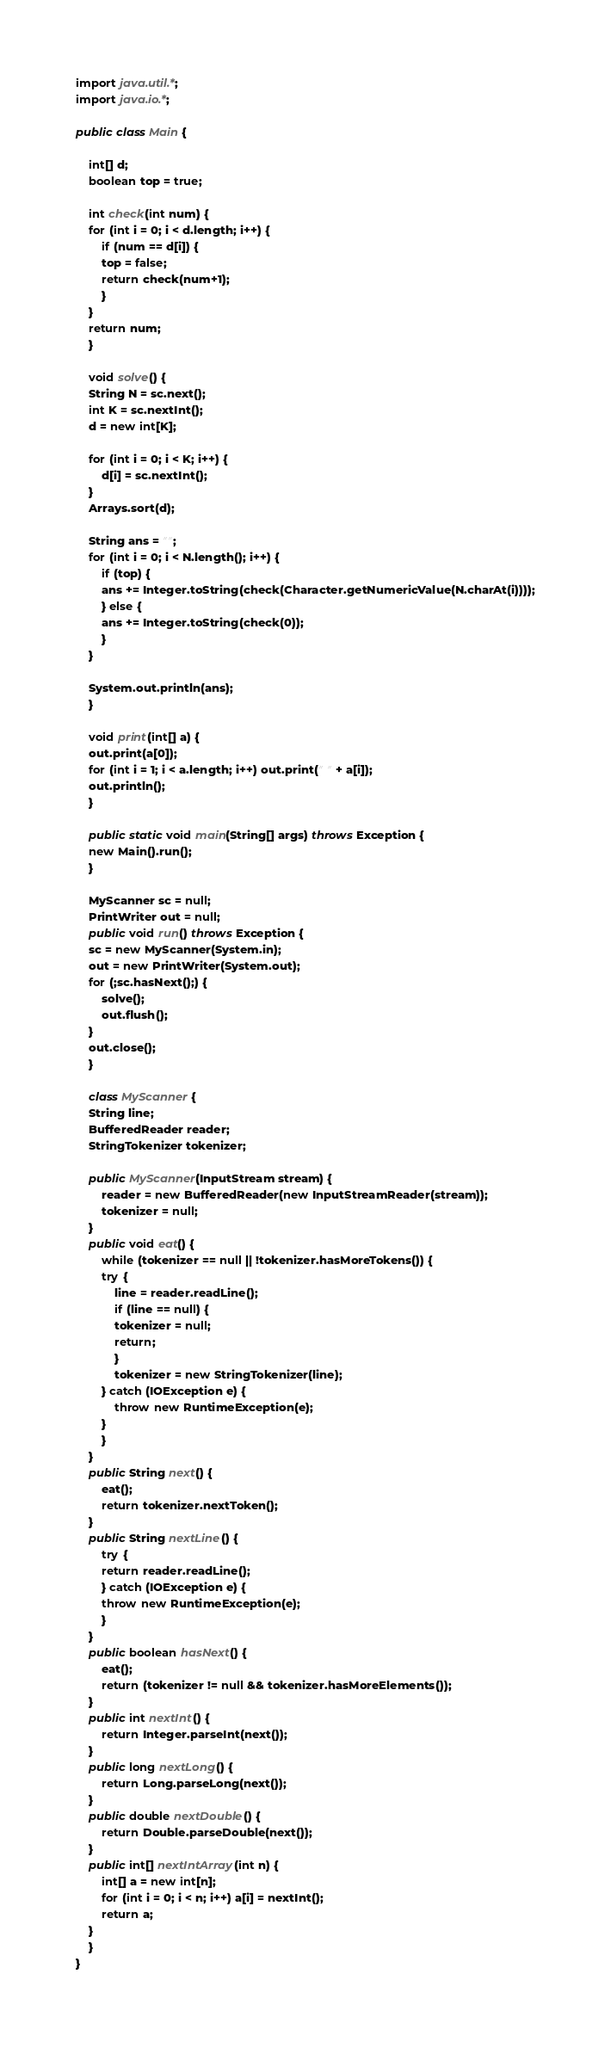Convert code to text. <code><loc_0><loc_0><loc_500><loc_500><_Java_>import java.util.*;
import java.io.*;

public class Main {

    int[] d;
    boolean top = true;

    int check(int num) {
	for (int i = 0; i < d.length; i++) {
	    if (num == d[i]) {
		top = false;
		return check(num+1);
	    }
	}
	return num;
    }

    void solve() {
	String N = sc.next();
	int K = sc.nextInt();
	d = new int[K];

	for (int i = 0; i < K; i++) {
	    d[i] = sc.nextInt();
	}
	Arrays.sort(d);

	String ans = "";
	for (int i = 0; i < N.length(); i++) {
	    if (top) {
		ans += Integer.toString(check(Character.getNumericValue(N.charAt(i))));
	    } else {
		ans += Integer.toString(check(0));
	    }
	}

	System.out.println(ans);
    }

    void print(int[] a) {
	out.print(a[0]);
	for (int i = 1; i < a.length; i++) out.print(" " + a[i]);
	out.println();
    }

    public static void main(String[] args) throws Exception {
	new Main().run();
    }

    MyScanner sc = null;
    PrintWriter out = null;
    public void run() throws Exception {
	sc = new MyScanner(System.in);
	out = new PrintWriter(System.out);
	for (;sc.hasNext();) {
	    solve();
	    out.flush();
	}
	out.close();
    }

    class MyScanner {
	String line;
	BufferedReader reader;
	StringTokenizer tokenizer;

	public MyScanner(InputStream stream) {
	    reader = new BufferedReader(new InputStreamReader(stream));
	    tokenizer = null;
	}
	public void eat() {
	    while (tokenizer == null || !tokenizer.hasMoreTokens()) {
		try {
		    line = reader.readLine();
		    if (line == null) {
			tokenizer = null;
			return;
		    }
		    tokenizer = new StringTokenizer(line);
		} catch (IOException e) {
		    throw new RuntimeException(e);
		}
	    }
	}
	public String next() {
	    eat();
	    return tokenizer.nextToken();
	}
	public String nextLine() {
	    try {
		return reader.readLine();
	    } catch (IOException e) {
		throw new RuntimeException(e);
	    }
	}
	public boolean hasNext() {
	    eat();
	    return (tokenizer != null && tokenizer.hasMoreElements());
	}
	public int nextInt() {
	    return Integer.parseInt(next());
	}
	public long nextLong() {
	    return Long.parseLong(next());
	}
	public double nextDouble() {
	    return Double.parseDouble(next());
	}
	public int[] nextIntArray(int n) {
	    int[] a = new int[n];
	    for (int i = 0; i < n; i++) a[i] = nextInt();
	    return a;
	}
    }
}
</code> 